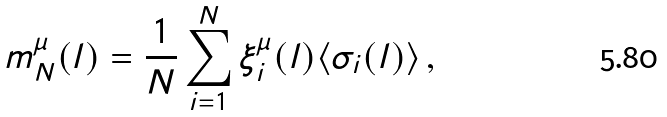Convert formula to latex. <formula><loc_0><loc_0><loc_500><loc_500>m ^ { \mu } _ { N } ( l ) = \frac { 1 } { N } \sum _ { i = 1 } ^ { N } \xi _ { i } ^ { \mu } ( l ) \langle \sigma _ { i } ( l ) \rangle \, ,</formula> 